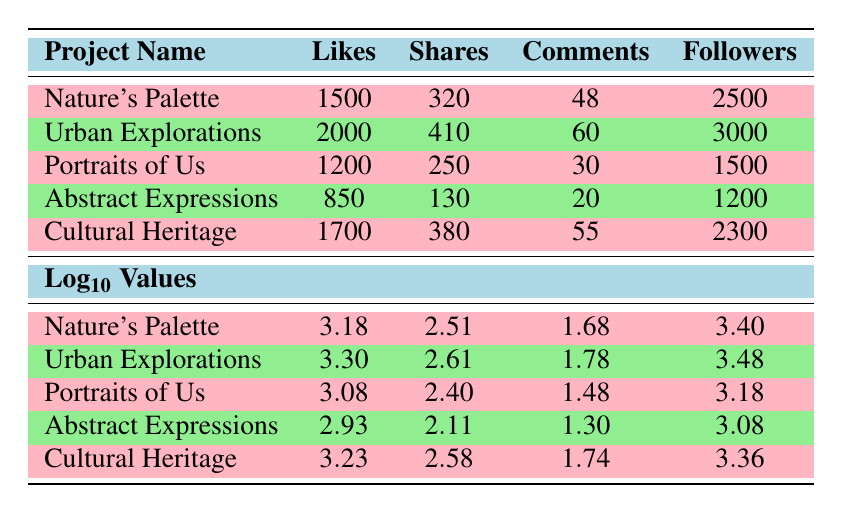What is the highest number of likes received among the projects? The project "Urban Explorations" has the highest number of likes at 2000, which is more than the other projects listed.
Answer: 2000 Which project received the least number of comments? "Abstract Expressions" received the least number of comments with a total of 20.
Answer: 20 What is the total number of shares across all projects? By adding the shares for each project: 320 + 410 + 250 + 130 + 380 = 1490, the total number of shares is 1490.
Answer: 1490 Did "Cultural Heritage" have more likes than "Portraits of Us"? "Cultural Heritage" received 1700 likes while "Portraits of Us" received 1200 likes; therefore, yes, "Cultural Heritage" had more likes.
Answer: Yes What is the average number of followers across all projects? The average number of followers is calculated by summing up all followers (2500 + 3000 + 1500 + 1200 + 2300 = 10700) and dividing by the number of projects (5). 10700 / 5 = 2140.
Answer: 2140 How many more likes does "Urban Explorations" have compared to "Abstract Expressions"? "Urban Explorations" has 2000 likes while "Abstract Expressions" has 850 likes. The difference is 2000 - 850 = 1150.
Answer: 1150 Which project had the largest number of followers relative to the number of likes it received? To find which project had the largest ratio of followers to likes, we can calculate the ratio for each project. For "Nature's Palette": 2500/1500 = 1.67, for "Urban Explorations": 3000/2000 = 1.5, for "Portraits of Us": 1500/1200 = 1.25, for "Abstract Expressions": 1200/850 = 1.41, and for "Cultural Heritage": 2300/1700 = 1.35. "Nature's Palette" has the highest ratio of 1.67.
Answer: Nature's Palette Is it true that "Portraits of Us" received more shares than "Abstract Expressions"? "Portraits of Us" received 250 shares, while "Abstract Expressions" received 130 shares. Thus, it is true that "Portraits of Us" received more shares.
Answer: Yes What is the logarithmic value of likes for "Cultural Heritage"? The logarithmic value of likes for "Cultural Heritage" is 3.23 as stated in the table.
Answer: 3.23 